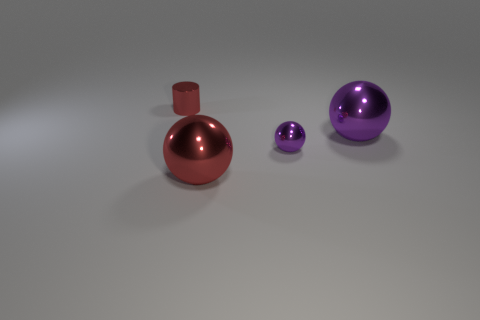What number of other balls have the same color as the tiny shiny ball?
Your response must be concise. 1. There is a red metal thing that is behind the red sphere in front of the tiny purple shiny ball; what shape is it?
Provide a short and direct response. Cylinder. What number of cylinders have the same material as the large red sphere?
Your response must be concise. 1. What is the shape of the metal thing left of the object in front of the small object that is in front of the small cylinder?
Ensure brevity in your answer.  Cylinder. There is a tiny metal object behind the small metallic ball; does it have the same color as the big thing that is in front of the small purple shiny thing?
Ensure brevity in your answer.  Yes. Are there fewer tiny purple metal spheres that are to the left of the big purple metallic sphere than balls in front of the small red shiny cylinder?
Ensure brevity in your answer.  Yes. Is there any other thing that is the same shape as the large purple shiny thing?
Provide a short and direct response. Yes. There is a tiny shiny object that is the same shape as the big purple metal thing; what color is it?
Your answer should be very brief. Purple. There is a large red metallic thing; is it the same shape as the red metallic object that is left of the large red metal object?
Ensure brevity in your answer.  No. What number of things are either objects right of the small red thing or small things to the right of the small red cylinder?
Your answer should be compact. 3. 